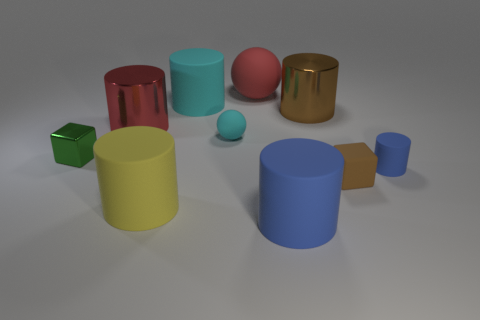What number of large things are left of the small cyan ball and behind the small green object?
Make the answer very short. 2. Is the number of big yellow objects that are behind the large rubber ball greater than the number of blue spheres?
Give a very brief answer. No. How many purple matte blocks have the same size as the yellow matte object?
Ensure brevity in your answer.  0. There is a cylinder that is the same color as the large matte sphere; what size is it?
Give a very brief answer. Large. What number of small objects are matte objects or purple matte cubes?
Ensure brevity in your answer.  3. How many small balls are there?
Make the answer very short. 1. Is the number of tiny brown blocks right of the brown cylinder the same as the number of big red objects on the left side of the big cyan matte cylinder?
Ensure brevity in your answer.  Yes. There is a red rubber thing; are there any big yellow cylinders on the right side of it?
Offer a terse response. No. There is a large matte cylinder that is behind the green metallic block; what color is it?
Ensure brevity in your answer.  Cyan. There is a large cylinder behind the metal object right of the tiny rubber ball; what is its material?
Make the answer very short. Rubber. 